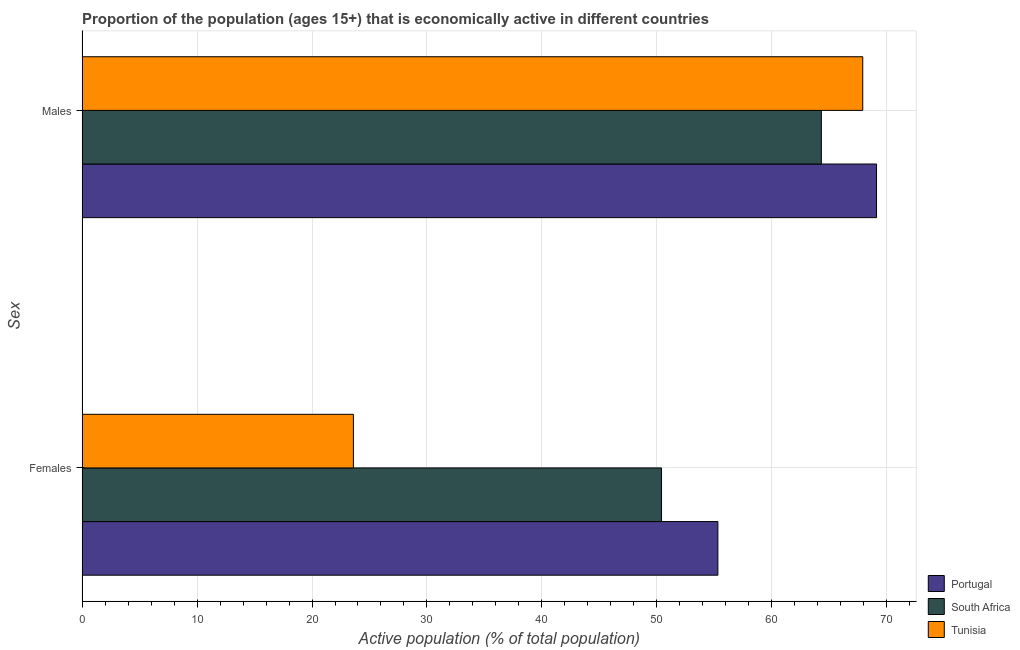How many groups of bars are there?
Your response must be concise. 2. Are the number of bars per tick equal to the number of legend labels?
Make the answer very short. Yes. Are the number of bars on each tick of the Y-axis equal?
Give a very brief answer. Yes. How many bars are there on the 2nd tick from the top?
Provide a short and direct response. 3. How many bars are there on the 1st tick from the bottom?
Provide a short and direct response. 3. What is the label of the 1st group of bars from the top?
Your answer should be compact. Males. What is the percentage of economically active female population in South Africa?
Your answer should be compact. 50.4. Across all countries, what is the maximum percentage of economically active male population?
Provide a short and direct response. 69.1. Across all countries, what is the minimum percentage of economically active female population?
Offer a terse response. 23.6. In which country was the percentage of economically active female population maximum?
Your answer should be very brief. Portugal. In which country was the percentage of economically active male population minimum?
Keep it short and to the point. South Africa. What is the total percentage of economically active male population in the graph?
Offer a terse response. 201.3. What is the difference between the percentage of economically active female population in South Africa and that in Portugal?
Your answer should be compact. -4.9. What is the difference between the percentage of economically active male population in South Africa and the percentage of economically active female population in Tunisia?
Provide a succinct answer. 40.7. What is the average percentage of economically active male population per country?
Make the answer very short. 67.1. What is the difference between the percentage of economically active female population and percentage of economically active male population in Tunisia?
Provide a succinct answer. -44.3. In how many countries, is the percentage of economically active female population greater than 10 %?
Offer a very short reply. 3. What is the ratio of the percentage of economically active male population in Tunisia to that in South Africa?
Ensure brevity in your answer.  1.06. Is the percentage of economically active male population in Portugal less than that in South Africa?
Offer a very short reply. No. What does the 2nd bar from the top in Females represents?
Make the answer very short. South Africa. What does the 2nd bar from the bottom in Females represents?
Provide a short and direct response. South Africa. How many bars are there?
Your answer should be very brief. 6. Does the graph contain any zero values?
Provide a succinct answer. No. How are the legend labels stacked?
Provide a short and direct response. Vertical. What is the title of the graph?
Keep it short and to the point. Proportion of the population (ages 15+) that is economically active in different countries. What is the label or title of the X-axis?
Offer a very short reply. Active population (% of total population). What is the label or title of the Y-axis?
Your response must be concise. Sex. What is the Active population (% of total population) of Portugal in Females?
Provide a short and direct response. 55.3. What is the Active population (% of total population) of South Africa in Females?
Provide a succinct answer. 50.4. What is the Active population (% of total population) in Tunisia in Females?
Your answer should be very brief. 23.6. What is the Active population (% of total population) in Portugal in Males?
Keep it short and to the point. 69.1. What is the Active population (% of total population) in South Africa in Males?
Provide a succinct answer. 64.3. What is the Active population (% of total population) of Tunisia in Males?
Offer a very short reply. 67.9. Across all Sex, what is the maximum Active population (% of total population) in Portugal?
Give a very brief answer. 69.1. Across all Sex, what is the maximum Active population (% of total population) in South Africa?
Your response must be concise. 64.3. Across all Sex, what is the maximum Active population (% of total population) in Tunisia?
Your answer should be compact. 67.9. Across all Sex, what is the minimum Active population (% of total population) of Portugal?
Make the answer very short. 55.3. Across all Sex, what is the minimum Active population (% of total population) in South Africa?
Your answer should be compact. 50.4. Across all Sex, what is the minimum Active population (% of total population) in Tunisia?
Your answer should be compact. 23.6. What is the total Active population (% of total population) of Portugal in the graph?
Provide a succinct answer. 124.4. What is the total Active population (% of total population) of South Africa in the graph?
Provide a short and direct response. 114.7. What is the total Active population (% of total population) in Tunisia in the graph?
Ensure brevity in your answer.  91.5. What is the difference between the Active population (% of total population) in South Africa in Females and that in Males?
Give a very brief answer. -13.9. What is the difference between the Active population (% of total population) of Tunisia in Females and that in Males?
Keep it short and to the point. -44.3. What is the difference between the Active population (% of total population) in Portugal in Females and the Active population (% of total population) in South Africa in Males?
Give a very brief answer. -9. What is the difference between the Active population (% of total population) in South Africa in Females and the Active population (% of total population) in Tunisia in Males?
Offer a very short reply. -17.5. What is the average Active population (% of total population) in Portugal per Sex?
Provide a short and direct response. 62.2. What is the average Active population (% of total population) in South Africa per Sex?
Ensure brevity in your answer.  57.35. What is the average Active population (% of total population) in Tunisia per Sex?
Offer a terse response. 45.75. What is the difference between the Active population (% of total population) of Portugal and Active population (% of total population) of Tunisia in Females?
Make the answer very short. 31.7. What is the difference between the Active population (% of total population) of South Africa and Active population (% of total population) of Tunisia in Females?
Your answer should be compact. 26.8. What is the difference between the Active population (% of total population) in Portugal and Active population (% of total population) in South Africa in Males?
Make the answer very short. 4.8. What is the difference between the Active population (% of total population) in Portugal and Active population (% of total population) in Tunisia in Males?
Your answer should be compact. 1.2. What is the difference between the Active population (% of total population) in South Africa and Active population (% of total population) in Tunisia in Males?
Provide a succinct answer. -3.6. What is the ratio of the Active population (% of total population) in Portugal in Females to that in Males?
Offer a very short reply. 0.8. What is the ratio of the Active population (% of total population) in South Africa in Females to that in Males?
Provide a short and direct response. 0.78. What is the ratio of the Active population (% of total population) in Tunisia in Females to that in Males?
Provide a short and direct response. 0.35. What is the difference between the highest and the second highest Active population (% of total population) in Portugal?
Keep it short and to the point. 13.8. What is the difference between the highest and the second highest Active population (% of total population) in South Africa?
Your response must be concise. 13.9. What is the difference between the highest and the second highest Active population (% of total population) in Tunisia?
Make the answer very short. 44.3. What is the difference between the highest and the lowest Active population (% of total population) of South Africa?
Offer a terse response. 13.9. What is the difference between the highest and the lowest Active population (% of total population) in Tunisia?
Give a very brief answer. 44.3. 